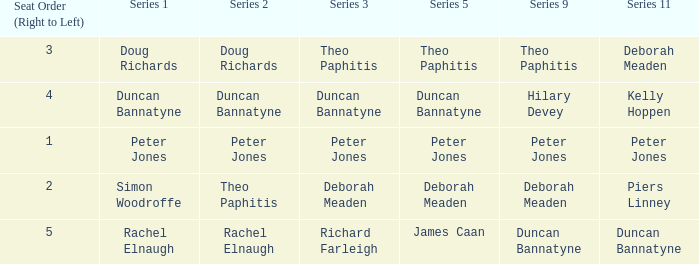Which series 2 has a series 3 featuring deborah meaden? Theo Paphitis. 